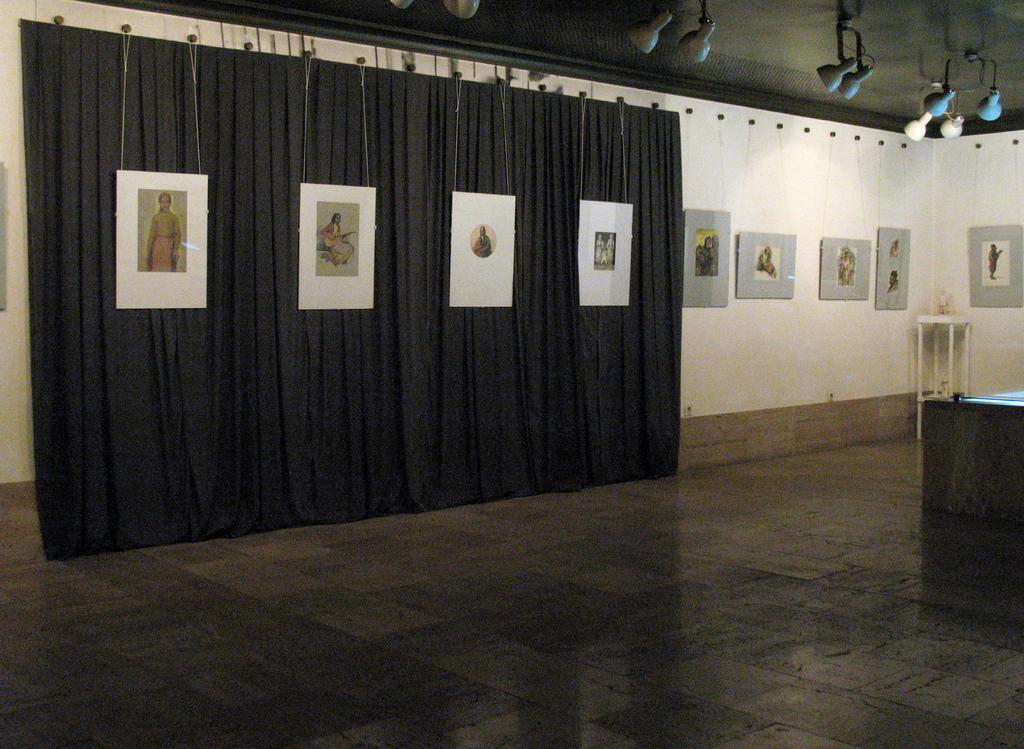What is hanging on the wall in the image? There are frames on the wall in the image. What type of window treatment is present in the image? There is a curtain in the image. What object is on the table in the image? There is a bottle on a table in the image. Where is the table located in the image? The table is in a corner of the image. What is providing illumination in the image? There are lights on top in the image. How many cracks can be seen on the curtain in the image? There are no cracks visible on the curtain in the image. What type of gate is present in the image? There is no gate present in the image. 